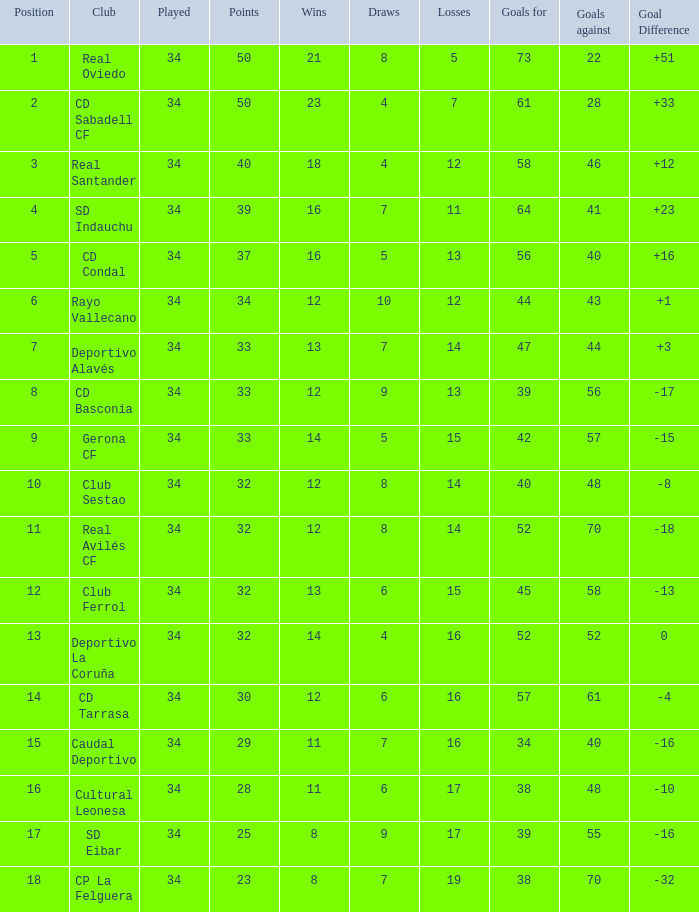Which victories have a goal margin greater than 0, and goals conceded higher than 40, and a ranking below 6, and a team of sd indauchu? 16.0. Could you help me parse every detail presented in this table? {'header': ['Position', 'Club', 'Played', 'Points', 'Wins', 'Draws', 'Losses', 'Goals for', 'Goals against', 'Goal Difference'], 'rows': [['1', 'Real Oviedo', '34', '50', '21', '8', '5', '73', '22', '+51'], ['2', 'CD Sabadell CF', '34', '50', '23', '4', '7', '61', '28', '+33'], ['3', 'Real Santander', '34', '40', '18', '4', '12', '58', '46', '+12'], ['4', 'SD Indauchu', '34', '39', '16', '7', '11', '64', '41', '+23'], ['5', 'CD Condal', '34', '37', '16', '5', '13', '56', '40', '+16'], ['6', 'Rayo Vallecano', '34', '34', '12', '10', '12', '44', '43', '+1'], ['7', 'Deportivo Alavés', '34', '33', '13', '7', '14', '47', '44', '+3'], ['8', 'CD Basconia', '34', '33', '12', '9', '13', '39', '56', '-17'], ['9', 'Gerona CF', '34', '33', '14', '5', '15', '42', '57', '-15'], ['10', 'Club Sestao', '34', '32', '12', '8', '14', '40', '48', '-8'], ['11', 'Real Avilés CF', '34', '32', '12', '8', '14', '52', '70', '-18'], ['12', 'Club Ferrol', '34', '32', '13', '6', '15', '45', '58', '-13'], ['13', 'Deportivo La Coruña', '34', '32', '14', '4', '16', '52', '52', '0'], ['14', 'CD Tarrasa', '34', '30', '12', '6', '16', '57', '61', '-4'], ['15', 'Caudal Deportivo', '34', '29', '11', '7', '16', '34', '40', '-16'], ['16', 'Cultural Leonesa', '34', '28', '11', '6', '17', '38', '48', '-10'], ['17', 'SD Eibar', '34', '25', '8', '9', '17', '39', '55', '-16'], ['18', 'CP La Felguera', '34', '23', '8', '7', '19', '38', '70', '-32']]} 